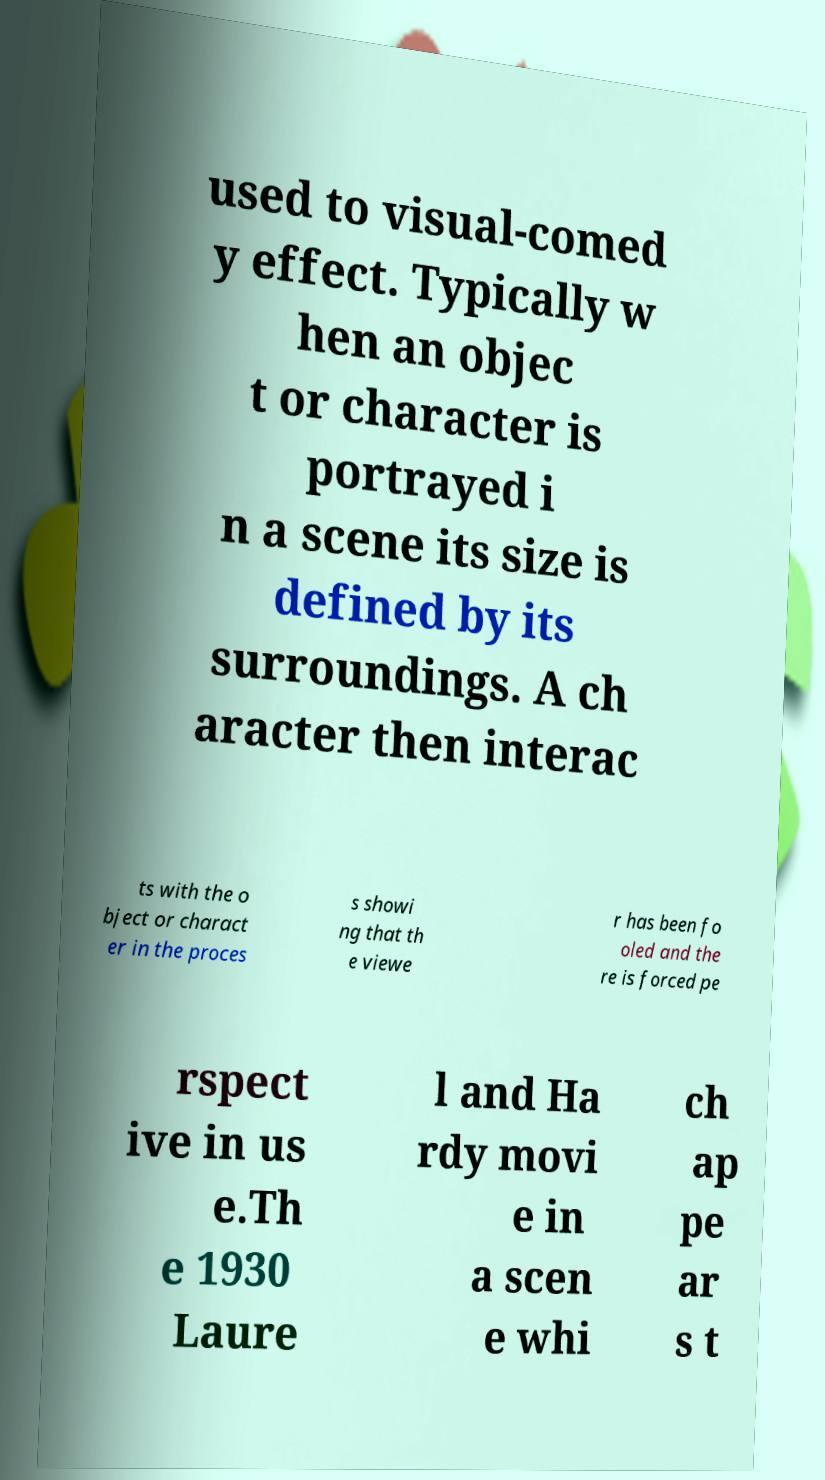Can you read and provide the text displayed in the image?This photo seems to have some interesting text. Can you extract and type it out for me? used to visual-comed y effect. Typically w hen an objec t or character is portrayed i n a scene its size is defined by its surroundings. A ch aracter then interac ts with the o bject or charact er in the proces s showi ng that th e viewe r has been fo oled and the re is forced pe rspect ive in us e.Th e 1930 Laure l and Ha rdy movi e in a scen e whi ch ap pe ar s t 